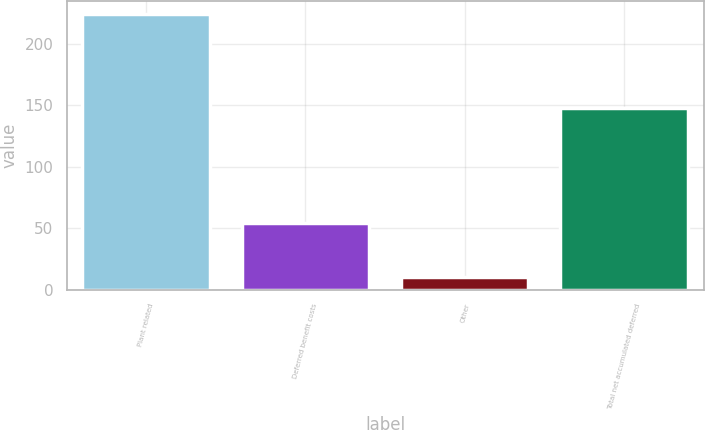Convert chart. <chart><loc_0><loc_0><loc_500><loc_500><bar_chart><fcel>Plant related<fcel>Deferred benefit costs<fcel>Other<fcel>Total net accumulated deferred<nl><fcel>224<fcel>54<fcel>10<fcel>148<nl></chart> 